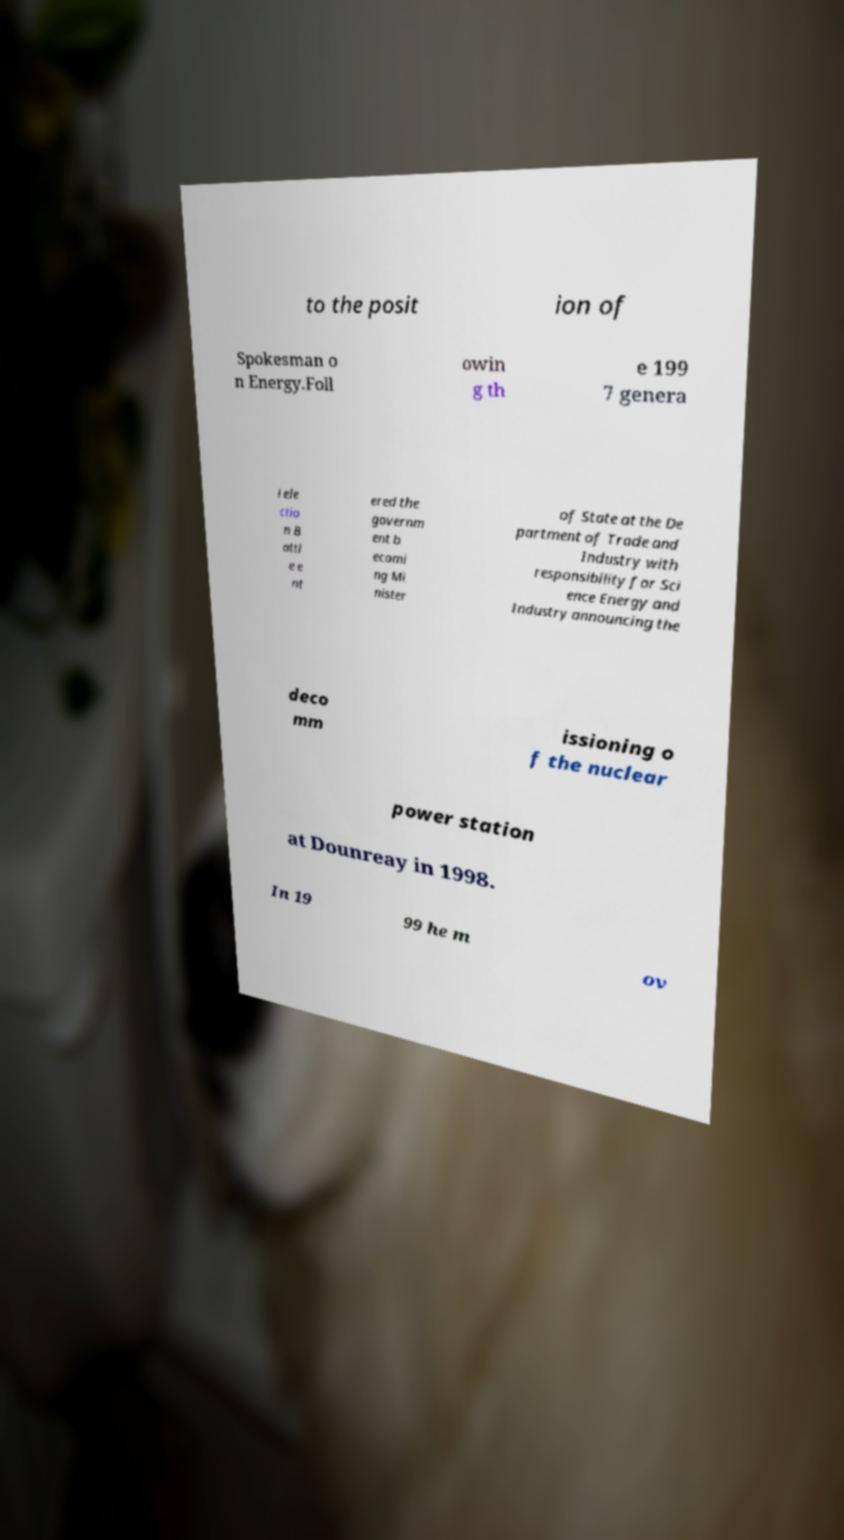I need the written content from this picture converted into text. Can you do that? to the posit ion of Spokesman o n Energy.Foll owin g th e 199 7 genera l ele ctio n B attl e e nt ered the governm ent b ecomi ng Mi nister of State at the De partment of Trade and Industry with responsibility for Sci ence Energy and Industry announcing the deco mm issioning o f the nuclear power station at Dounreay in 1998. In 19 99 he m ov 